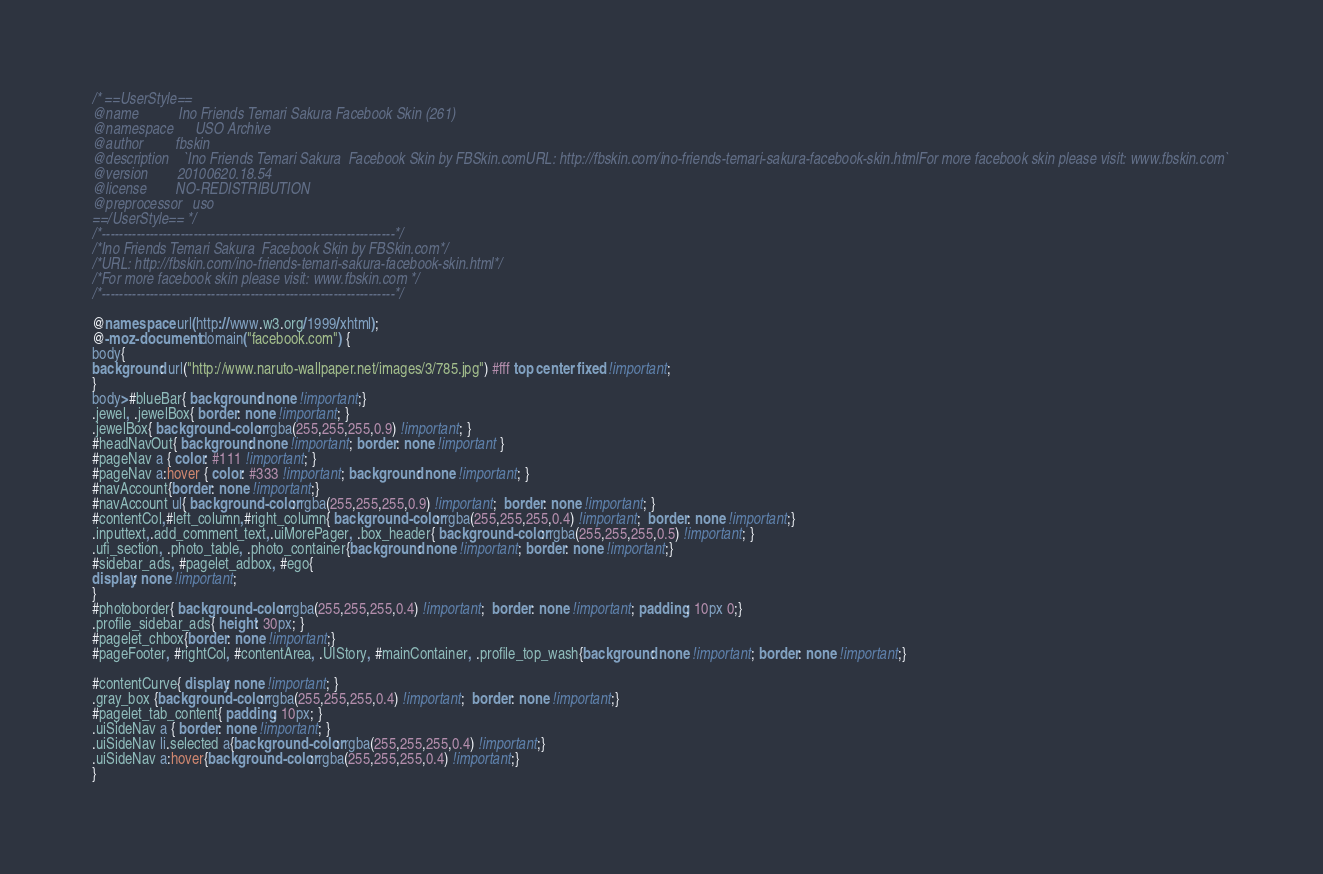Convert code to text. <code><loc_0><loc_0><loc_500><loc_500><_CSS_>/* ==UserStyle==
@name           Ino Friends Temari Sakura Facebook Skin (261)
@namespace      USO Archive
@author         fbskin
@description    `Ino Friends Temari Sakura  Facebook Skin by FBSkin.comURL: http://fbskin.com/ino-friends-temari-sakura-facebook-skin.htmlFor more facebook skin please visit: www.fbskin.com`
@version        20100620.18.54
@license        NO-REDISTRIBUTION
@preprocessor   uso
==/UserStyle== */
/*-------------------------------------------------------------------*/
/*Ino Friends Temari Sakura  Facebook Skin by FBSkin.com*/
/*URL: http://fbskin.com/ino-friends-temari-sakura-facebook-skin.html*/
/*For more facebook skin please visit: www.fbskin.com */
/*-------------------------------------------------------------------*/

@namespace url(http://www.w3.org/1999/xhtml);
@-moz-document domain("facebook.com") {
body{
background: url("http://www.naruto-wallpaper.net/images/3/785.jpg") #fff top center fixed !important;
}
body>#blueBar{ background: none !important;}
.jewel, .jewelBox{ border: none !important; }
.jewelBox{ background-color: rgba(255,255,255,0.9) !important; }
#headNavOut{ background: none !important; border: none !important }
#pageNav a { color: #111 !important; }
#pageNav a:hover { color: #333 !important; background: none !important; }
#navAccount{border: none !important;}
#navAccount ul{ background-color: rgba(255,255,255,0.9) !important;  border: none !important; }
#contentCol,#left_column,#right_column{ background-color: rgba(255,255,255,0.4) !important;  border: none !important;}
.inputtext,.add_comment_text,.uiMorePager, .box_header{ background-color: rgba(255,255,255,0.5) !important; }
.ufi_section, .photo_table, .photo_container{background: none !important; border: none !important;}
#sidebar_ads, #pagelet_adbox, #ego{
display: none !important;
}
#photoborder{ background-color: rgba(255,255,255,0.4) !important;  border: none !important; padding: 10px 0;}
.profile_sidebar_ads{ height: 30px; }
#pagelet_chbox{border: none !important;}
#pageFooter, #rightCol, #contentArea, .UIStory, #mainContainer, .profile_top_wash{background: none !important; border: none !important;}

#contentCurve{ display: none !important; }
.gray_box {background-color: rgba(255,255,255,0.4) !important;  border: none !important;}
#pagelet_tab_content{ padding: 10px; }
.uiSideNav a { border: none !important; }
.uiSideNav li.selected a{background-color: rgba(255,255,255,0.4) !important;}
.uiSideNav a:hover{background-color: rgba(255,255,255,0.4) !important;}
}</code> 